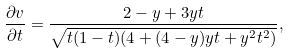Convert formula to latex. <formula><loc_0><loc_0><loc_500><loc_500>\frac { \partial v } { \partial t } = \frac { 2 - y + 3 y t } { \sqrt { t ( 1 - t ) ( 4 + ( 4 - y ) y t + y ^ { 2 } t ^ { 2 } ) } } ,</formula> 